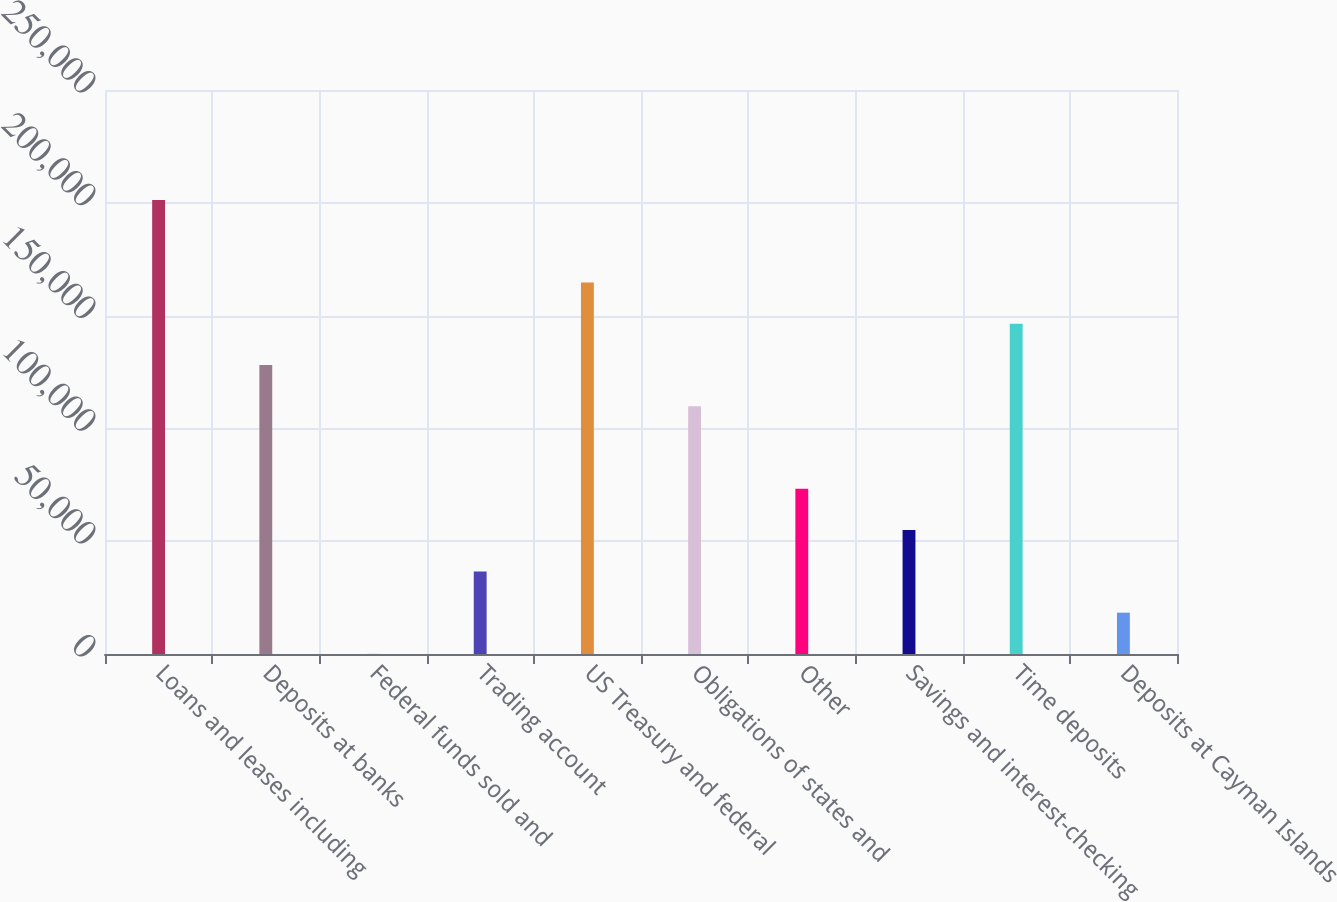<chart> <loc_0><loc_0><loc_500><loc_500><bar_chart><fcel>Loans and leases including<fcel>Deposits at banks<fcel>Federal funds sold and<fcel>Trading account<fcel>US Treasury and federal<fcel>Obligations of states and<fcel>Other<fcel>Savings and interest-checking<fcel>Time deposits<fcel>Deposits at Cayman Islands<nl><fcel>201270<fcel>128091<fcel>29<fcel>36618.2<fcel>164680<fcel>109797<fcel>73207.4<fcel>54912.8<fcel>146386<fcel>18323.6<nl></chart> 